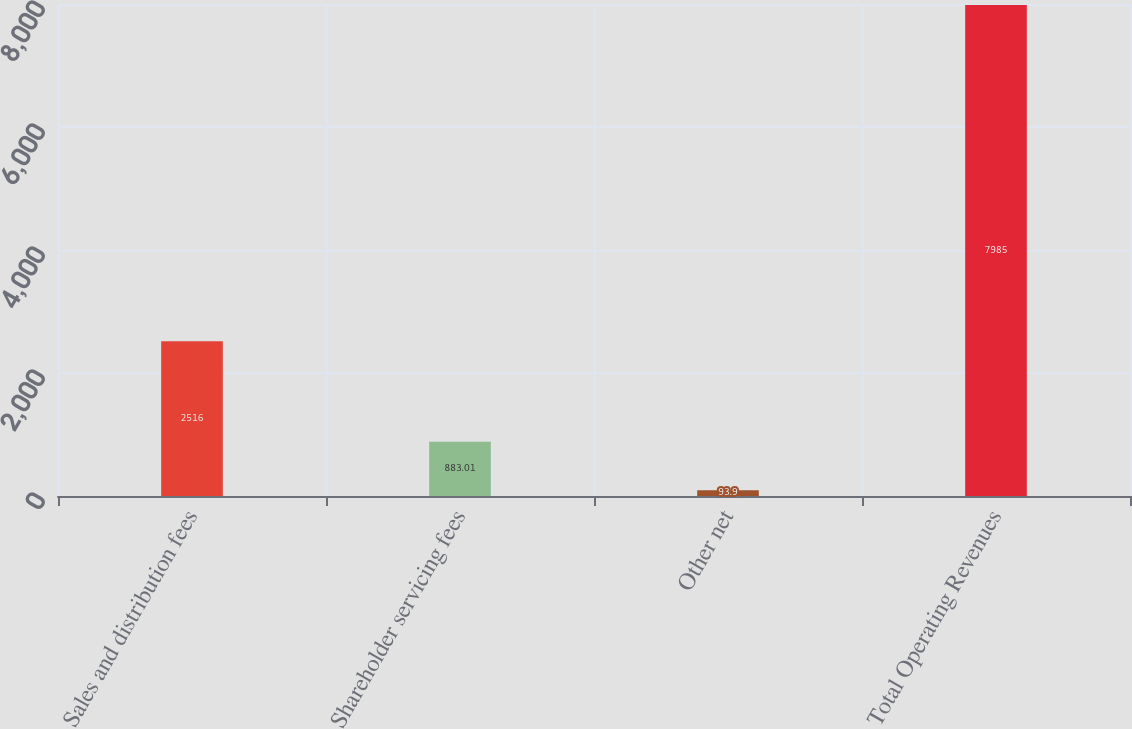Convert chart to OTSL. <chart><loc_0><loc_0><loc_500><loc_500><bar_chart><fcel>Sales and distribution fees<fcel>Shareholder servicing fees<fcel>Other net<fcel>Total Operating Revenues<nl><fcel>2516<fcel>883.01<fcel>93.9<fcel>7985<nl></chart> 